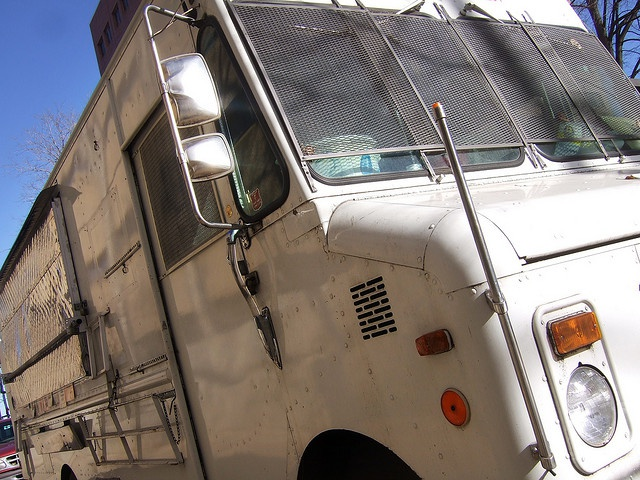Describe the objects in this image and their specific colors. I can see truck in gray, white, black, and blue tones and car in blue, black, gray, purple, and lightgray tones in this image. 